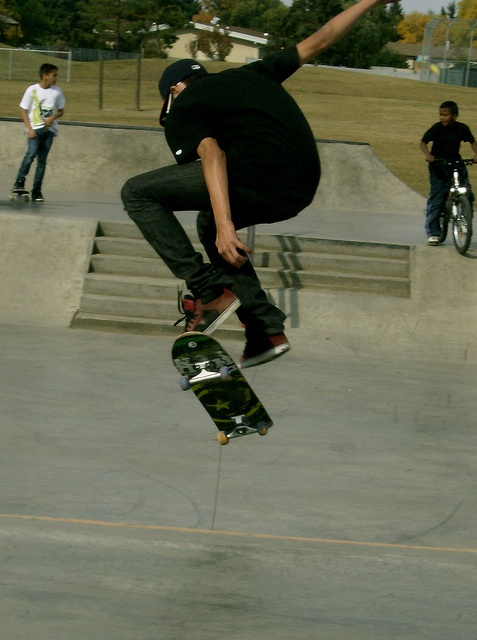Describe the objects in this image and their specific colors. I can see people in darkgreen, black, olive, and gray tones, skateboard in darkgreen, black, and gray tones, people in darkgreen, black, lightgray, gray, and olive tones, people in darkgreen, black, olive, and gray tones, and bicycle in darkgreen, black, and gray tones in this image. 